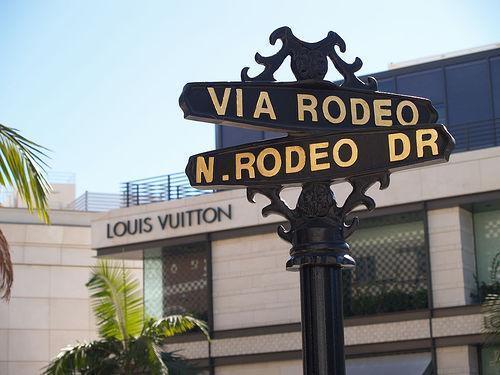How many windows are seen on building?
Give a very brief answer. 3. 